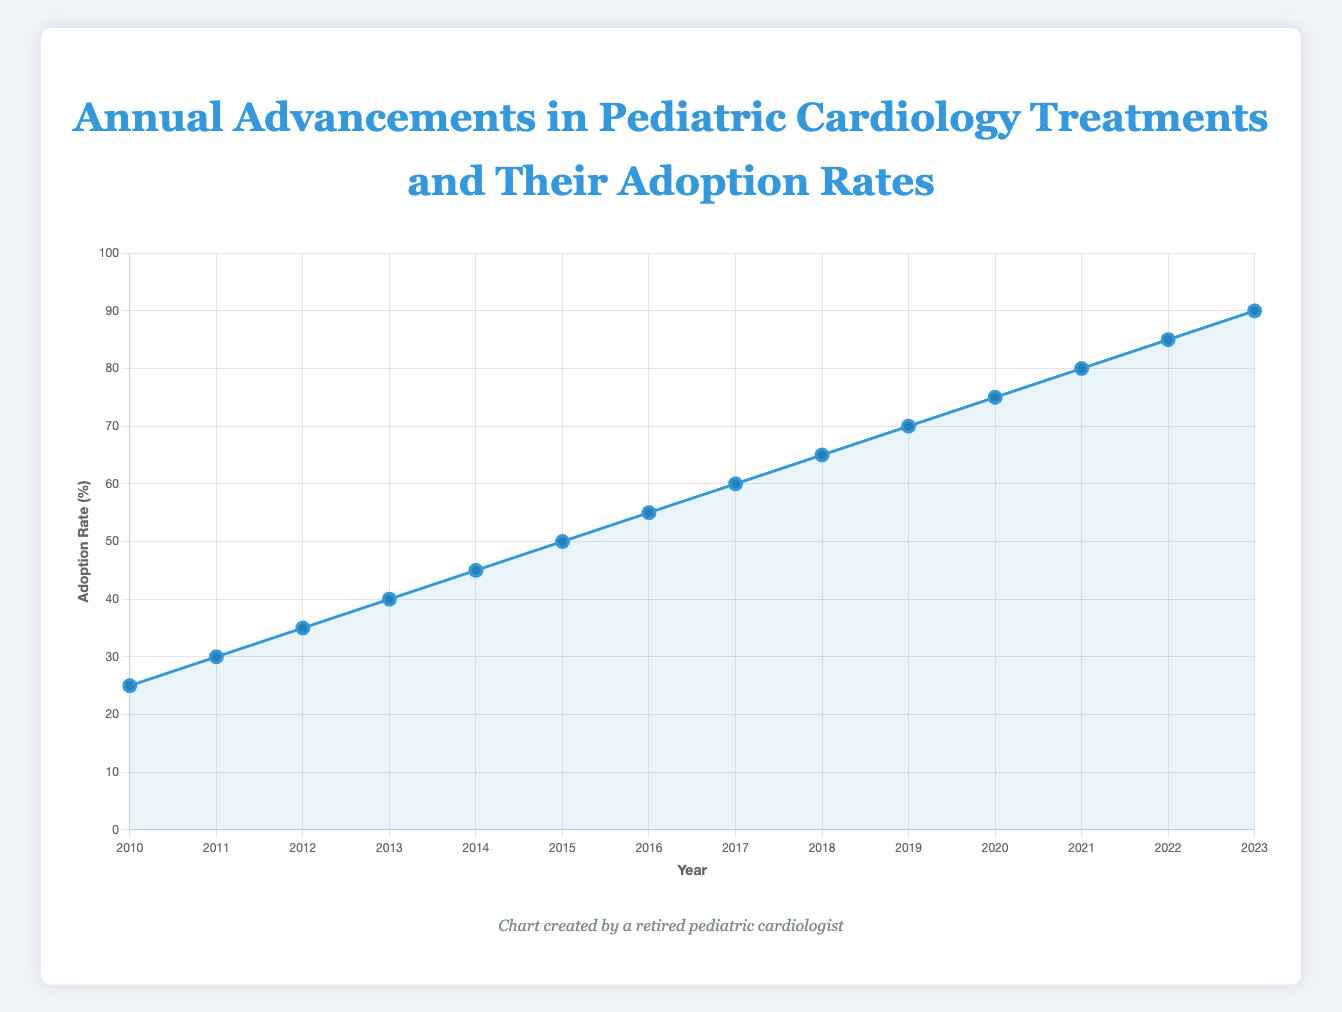What is the adoption rate for the "Free-standing" techniques introduced in 2015? According to the data presented on the chart for the year 2015, we locate the point corresponding to 2015 and read the adoption rate value.
Answer: 50 Which year had the highest adoption rate and what was the advancement? To find this, look for the highest point on the line chart. The highest adoption rate value is at 2023, where the advancement was "Genetic Screening for Cardiac Anomalies."
Answer: 2023, Genetic Screening for Cardiac Anomalies What is the difference in adoption rates between "Transcatheter Pulmonary Valve Replacement" and "Wearable Cardiac Monitoring Devices"? Read the adoption rates for the advancements from the respective years on the chart. "Transcatheter Pulmonary Valve Replacement" was introduced in 2010 with an adoption rate of 25%. "Wearable Cardiac Monitoring Devices" was introduced in 2021 with an adoption rate of 80%. Calculating the difference: 80% - 25% = 55%.
Answer: 55% Over what period did the adoption rate grow from 25% to 90%? The adoption rate of 25% is recorded at 2010 and 90% at 2023. The period between these years is from 2010 to 2023, which is 13 years.
Answer: 13 years What is the median adoption rate of the advancements listed? First, list the adoption rates in ascending order: 25, 30, 35, 40, 45, 50, 55, 60, 65, 70, 75, 80, 85, 90. Since there are 14 data points, the median is the average of the 7th and 8th values. Calculating: (55 + 60) / 2 = 57.5.
Answer: 57.5 Which two consecutive years had the highest increase in adoption rate and by how much? Compare the adoption rates year by year and find the two consecutive years with the greatest increase. The years with the highest increase are 2022 (85%) to 2023 (90%), resulting in an increase of 90% - 85% = 5%.
Answer: 2022 to 2023, 5% What advancement was associated with the adoption rate of 45%? Identify the year where the adoption rate was 45%. According to the chart, this adoption rate is in 2014. The advancement for 2014 is "Cardiac MRI Innovations."
Answer: Cardiac MRI Innovations From the visual attributes, describe the trend in the adoption rate from 2010 to 2023. Observing the line chart, the trend shows a steady increase in the adoption rate from 2010 (25%) to 2023 (90%). The line gradually ascends over this period, indicating a continuous growth in adoption.
Answer: Steady increase 